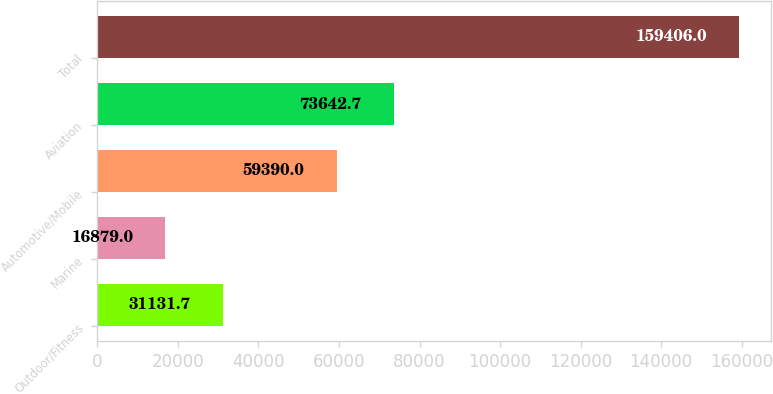<chart> <loc_0><loc_0><loc_500><loc_500><bar_chart><fcel>Outdoor/Fitness<fcel>Marine<fcel>Automotive/Mobile<fcel>Aviation<fcel>Total<nl><fcel>31131.7<fcel>16879<fcel>59390<fcel>73642.7<fcel>159406<nl></chart> 